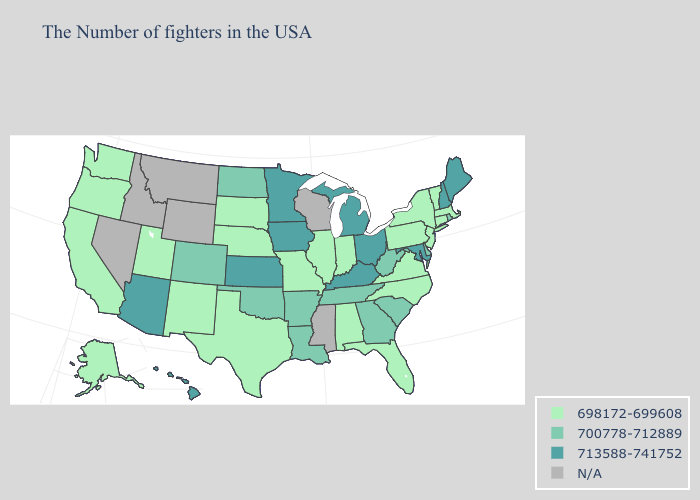Which states have the highest value in the USA?
Write a very short answer. Maine, New Hampshire, Maryland, Ohio, Michigan, Kentucky, Minnesota, Iowa, Kansas, Arizona, Hawaii. Which states hav the highest value in the South?
Quick response, please. Maryland, Kentucky. Does Alaska have the highest value in the USA?
Keep it brief. No. What is the highest value in states that border New Jersey?
Be succinct. 700778-712889. Among the states that border Nebraska , does Kansas have the highest value?
Concise answer only. Yes. Name the states that have a value in the range 700778-712889?
Short answer required. Rhode Island, Delaware, South Carolina, West Virginia, Georgia, Tennessee, Louisiana, Arkansas, Oklahoma, North Dakota, Colorado. Does the first symbol in the legend represent the smallest category?
Be succinct. Yes. What is the value of Connecticut?
Concise answer only. 698172-699608. What is the value of Rhode Island?
Give a very brief answer. 700778-712889. Name the states that have a value in the range 713588-741752?
Keep it brief. Maine, New Hampshire, Maryland, Ohio, Michigan, Kentucky, Minnesota, Iowa, Kansas, Arizona, Hawaii. Name the states that have a value in the range N/A?
Be succinct. Wisconsin, Mississippi, Wyoming, Montana, Idaho, Nevada. Does Connecticut have the lowest value in the Northeast?
Keep it brief. Yes. Does Maine have the lowest value in the Northeast?
Write a very short answer. No. Name the states that have a value in the range 713588-741752?
Quick response, please. Maine, New Hampshire, Maryland, Ohio, Michigan, Kentucky, Minnesota, Iowa, Kansas, Arizona, Hawaii. 